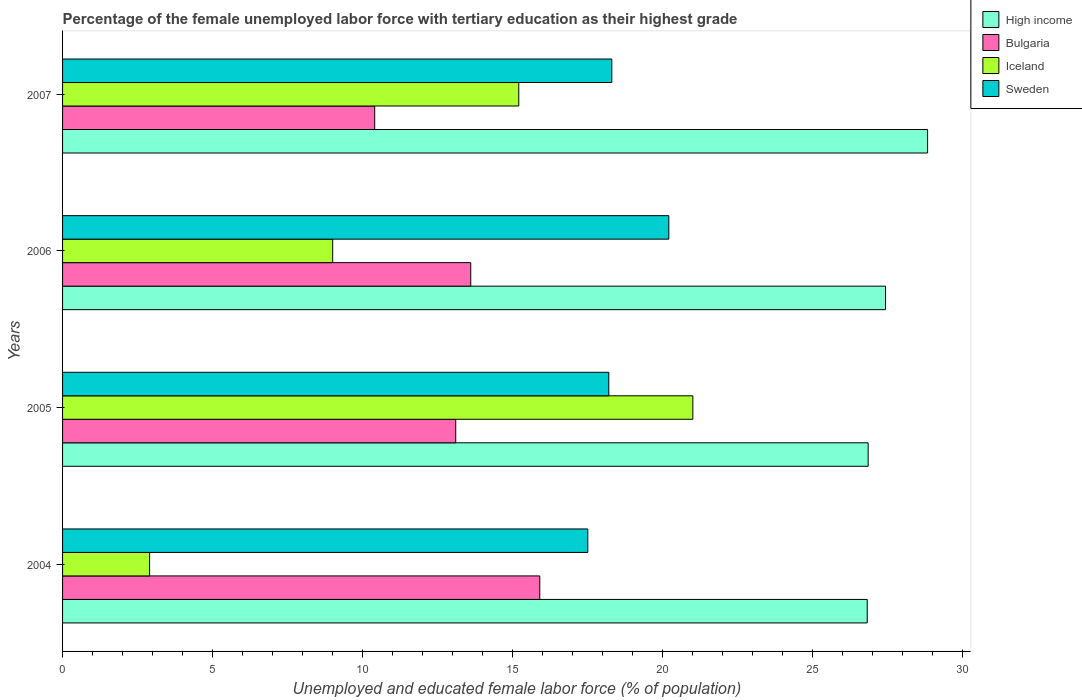How many groups of bars are there?
Make the answer very short. 4. Are the number of bars per tick equal to the number of legend labels?
Your answer should be very brief. Yes. How many bars are there on the 1st tick from the top?
Make the answer very short. 4. How many bars are there on the 4th tick from the bottom?
Provide a short and direct response. 4. What is the label of the 1st group of bars from the top?
Provide a succinct answer. 2007. What is the percentage of the unemployed female labor force with tertiary education in High income in 2007?
Your response must be concise. 28.82. Across all years, what is the minimum percentage of the unemployed female labor force with tertiary education in Iceland?
Your answer should be very brief. 2.9. In which year was the percentage of the unemployed female labor force with tertiary education in Iceland maximum?
Keep it short and to the point. 2005. In which year was the percentage of the unemployed female labor force with tertiary education in Bulgaria minimum?
Provide a succinct answer. 2007. What is the total percentage of the unemployed female labor force with tertiary education in Iceland in the graph?
Give a very brief answer. 48.1. What is the difference between the percentage of the unemployed female labor force with tertiary education in Sweden in 2005 and that in 2007?
Give a very brief answer. -0.1. What is the difference between the percentage of the unemployed female labor force with tertiary education in High income in 2004 and the percentage of the unemployed female labor force with tertiary education in Iceland in 2006?
Your response must be concise. 17.81. What is the average percentage of the unemployed female labor force with tertiary education in Sweden per year?
Keep it short and to the point. 18.55. In the year 2004, what is the difference between the percentage of the unemployed female labor force with tertiary education in Bulgaria and percentage of the unemployed female labor force with tertiary education in High income?
Make the answer very short. -10.91. In how many years, is the percentage of the unemployed female labor force with tertiary education in Iceland greater than 17 %?
Your response must be concise. 1. What is the ratio of the percentage of the unemployed female labor force with tertiary education in Sweden in 2006 to that in 2007?
Your response must be concise. 1.1. Is the percentage of the unemployed female labor force with tertiary education in Iceland in 2005 less than that in 2007?
Make the answer very short. No. Is the difference between the percentage of the unemployed female labor force with tertiary education in Bulgaria in 2005 and 2006 greater than the difference between the percentage of the unemployed female labor force with tertiary education in High income in 2005 and 2006?
Offer a terse response. Yes. What is the difference between the highest and the second highest percentage of the unemployed female labor force with tertiary education in Iceland?
Ensure brevity in your answer.  5.8. What is the difference between the highest and the lowest percentage of the unemployed female labor force with tertiary education in Iceland?
Your answer should be very brief. 18.1. What does the 2nd bar from the top in 2007 represents?
Your answer should be compact. Iceland. What does the 4th bar from the bottom in 2004 represents?
Your answer should be compact. Sweden. Is it the case that in every year, the sum of the percentage of the unemployed female labor force with tertiary education in Sweden and percentage of the unemployed female labor force with tertiary education in Iceland is greater than the percentage of the unemployed female labor force with tertiary education in High income?
Keep it short and to the point. No. Are the values on the major ticks of X-axis written in scientific E-notation?
Offer a very short reply. No. Does the graph contain any zero values?
Offer a very short reply. No. How are the legend labels stacked?
Provide a succinct answer. Vertical. What is the title of the graph?
Make the answer very short. Percentage of the female unemployed labor force with tertiary education as their highest grade. Does "Nigeria" appear as one of the legend labels in the graph?
Provide a succinct answer. No. What is the label or title of the X-axis?
Offer a terse response. Unemployed and educated female labor force (% of population). What is the label or title of the Y-axis?
Your answer should be compact. Years. What is the Unemployed and educated female labor force (% of population) in High income in 2004?
Give a very brief answer. 26.81. What is the Unemployed and educated female labor force (% of population) of Bulgaria in 2004?
Provide a succinct answer. 15.9. What is the Unemployed and educated female labor force (% of population) in Iceland in 2004?
Your answer should be compact. 2.9. What is the Unemployed and educated female labor force (% of population) in High income in 2005?
Offer a terse response. 26.84. What is the Unemployed and educated female labor force (% of population) in Bulgaria in 2005?
Give a very brief answer. 13.1. What is the Unemployed and educated female labor force (% of population) in Iceland in 2005?
Keep it short and to the point. 21. What is the Unemployed and educated female labor force (% of population) of Sweden in 2005?
Your answer should be very brief. 18.2. What is the Unemployed and educated female labor force (% of population) of High income in 2006?
Your answer should be very brief. 27.42. What is the Unemployed and educated female labor force (% of population) in Bulgaria in 2006?
Provide a short and direct response. 13.6. What is the Unemployed and educated female labor force (% of population) of Sweden in 2006?
Your answer should be compact. 20.2. What is the Unemployed and educated female labor force (% of population) in High income in 2007?
Your response must be concise. 28.82. What is the Unemployed and educated female labor force (% of population) of Bulgaria in 2007?
Offer a very short reply. 10.4. What is the Unemployed and educated female labor force (% of population) of Iceland in 2007?
Ensure brevity in your answer.  15.2. What is the Unemployed and educated female labor force (% of population) of Sweden in 2007?
Provide a succinct answer. 18.3. Across all years, what is the maximum Unemployed and educated female labor force (% of population) of High income?
Provide a short and direct response. 28.82. Across all years, what is the maximum Unemployed and educated female labor force (% of population) in Bulgaria?
Your response must be concise. 15.9. Across all years, what is the maximum Unemployed and educated female labor force (% of population) of Sweden?
Make the answer very short. 20.2. Across all years, what is the minimum Unemployed and educated female labor force (% of population) in High income?
Your answer should be very brief. 26.81. Across all years, what is the minimum Unemployed and educated female labor force (% of population) in Bulgaria?
Provide a succinct answer. 10.4. Across all years, what is the minimum Unemployed and educated female labor force (% of population) of Iceland?
Your response must be concise. 2.9. What is the total Unemployed and educated female labor force (% of population) of High income in the graph?
Ensure brevity in your answer.  109.89. What is the total Unemployed and educated female labor force (% of population) of Bulgaria in the graph?
Give a very brief answer. 53. What is the total Unemployed and educated female labor force (% of population) of Iceland in the graph?
Offer a terse response. 48.1. What is the total Unemployed and educated female labor force (% of population) in Sweden in the graph?
Provide a succinct answer. 74.2. What is the difference between the Unemployed and educated female labor force (% of population) of High income in 2004 and that in 2005?
Your response must be concise. -0.03. What is the difference between the Unemployed and educated female labor force (% of population) in Iceland in 2004 and that in 2005?
Your answer should be very brief. -18.1. What is the difference between the Unemployed and educated female labor force (% of population) of Sweden in 2004 and that in 2005?
Your response must be concise. -0.7. What is the difference between the Unemployed and educated female labor force (% of population) of High income in 2004 and that in 2006?
Your response must be concise. -0.61. What is the difference between the Unemployed and educated female labor force (% of population) of Bulgaria in 2004 and that in 2006?
Offer a very short reply. 2.3. What is the difference between the Unemployed and educated female labor force (% of population) in High income in 2004 and that in 2007?
Your response must be concise. -2.01. What is the difference between the Unemployed and educated female labor force (% of population) in Iceland in 2004 and that in 2007?
Ensure brevity in your answer.  -12.3. What is the difference between the Unemployed and educated female labor force (% of population) in Sweden in 2004 and that in 2007?
Your response must be concise. -0.8. What is the difference between the Unemployed and educated female labor force (% of population) in High income in 2005 and that in 2006?
Ensure brevity in your answer.  -0.58. What is the difference between the Unemployed and educated female labor force (% of population) of Bulgaria in 2005 and that in 2006?
Ensure brevity in your answer.  -0.5. What is the difference between the Unemployed and educated female labor force (% of population) of Iceland in 2005 and that in 2006?
Keep it short and to the point. 12. What is the difference between the Unemployed and educated female labor force (% of population) of Sweden in 2005 and that in 2006?
Provide a short and direct response. -2. What is the difference between the Unemployed and educated female labor force (% of population) in High income in 2005 and that in 2007?
Your answer should be very brief. -1.98. What is the difference between the Unemployed and educated female labor force (% of population) of Sweden in 2005 and that in 2007?
Ensure brevity in your answer.  -0.1. What is the difference between the Unemployed and educated female labor force (% of population) in High income in 2006 and that in 2007?
Offer a very short reply. -1.4. What is the difference between the Unemployed and educated female labor force (% of population) in Bulgaria in 2006 and that in 2007?
Offer a terse response. 3.2. What is the difference between the Unemployed and educated female labor force (% of population) of High income in 2004 and the Unemployed and educated female labor force (% of population) of Bulgaria in 2005?
Ensure brevity in your answer.  13.71. What is the difference between the Unemployed and educated female labor force (% of population) of High income in 2004 and the Unemployed and educated female labor force (% of population) of Iceland in 2005?
Ensure brevity in your answer.  5.81. What is the difference between the Unemployed and educated female labor force (% of population) in High income in 2004 and the Unemployed and educated female labor force (% of population) in Sweden in 2005?
Your response must be concise. 8.61. What is the difference between the Unemployed and educated female labor force (% of population) of Bulgaria in 2004 and the Unemployed and educated female labor force (% of population) of Sweden in 2005?
Ensure brevity in your answer.  -2.3. What is the difference between the Unemployed and educated female labor force (% of population) of Iceland in 2004 and the Unemployed and educated female labor force (% of population) of Sweden in 2005?
Keep it short and to the point. -15.3. What is the difference between the Unemployed and educated female labor force (% of population) of High income in 2004 and the Unemployed and educated female labor force (% of population) of Bulgaria in 2006?
Offer a terse response. 13.21. What is the difference between the Unemployed and educated female labor force (% of population) of High income in 2004 and the Unemployed and educated female labor force (% of population) of Iceland in 2006?
Your answer should be compact. 17.81. What is the difference between the Unemployed and educated female labor force (% of population) of High income in 2004 and the Unemployed and educated female labor force (% of population) of Sweden in 2006?
Make the answer very short. 6.61. What is the difference between the Unemployed and educated female labor force (% of population) in Iceland in 2004 and the Unemployed and educated female labor force (% of population) in Sweden in 2006?
Ensure brevity in your answer.  -17.3. What is the difference between the Unemployed and educated female labor force (% of population) in High income in 2004 and the Unemployed and educated female labor force (% of population) in Bulgaria in 2007?
Make the answer very short. 16.41. What is the difference between the Unemployed and educated female labor force (% of population) in High income in 2004 and the Unemployed and educated female labor force (% of population) in Iceland in 2007?
Your response must be concise. 11.61. What is the difference between the Unemployed and educated female labor force (% of population) of High income in 2004 and the Unemployed and educated female labor force (% of population) of Sweden in 2007?
Ensure brevity in your answer.  8.51. What is the difference between the Unemployed and educated female labor force (% of population) in Iceland in 2004 and the Unemployed and educated female labor force (% of population) in Sweden in 2007?
Make the answer very short. -15.4. What is the difference between the Unemployed and educated female labor force (% of population) of High income in 2005 and the Unemployed and educated female labor force (% of population) of Bulgaria in 2006?
Keep it short and to the point. 13.24. What is the difference between the Unemployed and educated female labor force (% of population) in High income in 2005 and the Unemployed and educated female labor force (% of population) in Iceland in 2006?
Offer a very short reply. 17.84. What is the difference between the Unemployed and educated female labor force (% of population) in High income in 2005 and the Unemployed and educated female labor force (% of population) in Sweden in 2006?
Ensure brevity in your answer.  6.64. What is the difference between the Unemployed and educated female labor force (% of population) of Iceland in 2005 and the Unemployed and educated female labor force (% of population) of Sweden in 2006?
Offer a terse response. 0.8. What is the difference between the Unemployed and educated female labor force (% of population) of High income in 2005 and the Unemployed and educated female labor force (% of population) of Bulgaria in 2007?
Your response must be concise. 16.44. What is the difference between the Unemployed and educated female labor force (% of population) of High income in 2005 and the Unemployed and educated female labor force (% of population) of Iceland in 2007?
Provide a short and direct response. 11.64. What is the difference between the Unemployed and educated female labor force (% of population) in High income in 2005 and the Unemployed and educated female labor force (% of population) in Sweden in 2007?
Your answer should be very brief. 8.54. What is the difference between the Unemployed and educated female labor force (% of population) in Bulgaria in 2005 and the Unemployed and educated female labor force (% of population) in Sweden in 2007?
Ensure brevity in your answer.  -5.2. What is the difference between the Unemployed and educated female labor force (% of population) in Iceland in 2005 and the Unemployed and educated female labor force (% of population) in Sweden in 2007?
Provide a short and direct response. 2.7. What is the difference between the Unemployed and educated female labor force (% of population) of High income in 2006 and the Unemployed and educated female labor force (% of population) of Bulgaria in 2007?
Offer a very short reply. 17.02. What is the difference between the Unemployed and educated female labor force (% of population) of High income in 2006 and the Unemployed and educated female labor force (% of population) of Iceland in 2007?
Keep it short and to the point. 12.22. What is the difference between the Unemployed and educated female labor force (% of population) of High income in 2006 and the Unemployed and educated female labor force (% of population) of Sweden in 2007?
Offer a terse response. 9.12. What is the difference between the Unemployed and educated female labor force (% of population) in Bulgaria in 2006 and the Unemployed and educated female labor force (% of population) in Iceland in 2007?
Your response must be concise. -1.6. What is the difference between the Unemployed and educated female labor force (% of population) in Iceland in 2006 and the Unemployed and educated female labor force (% of population) in Sweden in 2007?
Your response must be concise. -9.3. What is the average Unemployed and educated female labor force (% of population) of High income per year?
Your answer should be very brief. 27.47. What is the average Unemployed and educated female labor force (% of population) of Bulgaria per year?
Give a very brief answer. 13.25. What is the average Unemployed and educated female labor force (% of population) of Iceland per year?
Provide a succinct answer. 12.03. What is the average Unemployed and educated female labor force (% of population) in Sweden per year?
Your answer should be compact. 18.55. In the year 2004, what is the difference between the Unemployed and educated female labor force (% of population) in High income and Unemployed and educated female labor force (% of population) in Bulgaria?
Provide a short and direct response. 10.91. In the year 2004, what is the difference between the Unemployed and educated female labor force (% of population) in High income and Unemployed and educated female labor force (% of population) in Iceland?
Keep it short and to the point. 23.91. In the year 2004, what is the difference between the Unemployed and educated female labor force (% of population) of High income and Unemployed and educated female labor force (% of population) of Sweden?
Your response must be concise. 9.31. In the year 2004, what is the difference between the Unemployed and educated female labor force (% of population) of Bulgaria and Unemployed and educated female labor force (% of population) of Sweden?
Keep it short and to the point. -1.6. In the year 2004, what is the difference between the Unemployed and educated female labor force (% of population) in Iceland and Unemployed and educated female labor force (% of population) in Sweden?
Your response must be concise. -14.6. In the year 2005, what is the difference between the Unemployed and educated female labor force (% of population) in High income and Unemployed and educated female labor force (% of population) in Bulgaria?
Ensure brevity in your answer.  13.74. In the year 2005, what is the difference between the Unemployed and educated female labor force (% of population) of High income and Unemployed and educated female labor force (% of population) of Iceland?
Provide a short and direct response. 5.84. In the year 2005, what is the difference between the Unemployed and educated female labor force (% of population) in High income and Unemployed and educated female labor force (% of population) in Sweden?
Keep it short and to the point. 8.64. In the year 2005, what is the difference between the Unemployed and educated female labor force (% of population) of Bulgaria and Unemployed and educated female labor force (% of population) of Iceland?
Ensure brevity in your answer.  -7.9. In the year 2006, what is the difference between the Unemployed and educated female labor force (% of population) of High income and Unemployed and educated female labor force (% of population) of Bulgaria?
Provide a short and direct response. 13.82. In the year 2006, what is the difference between the Unemployed and educated female labor force (% of population) in High income and Unemployed and educated female labor force (% of population) in Iceland?
Your answer should be compact. 18.42. In the year 2006, what is the difference between the Unemployed and educated female labor force (% of population) in High income and Unemployed and educated female labor force (% of population) in Sweden?
Provide a succinct answer. 7.22. In the year 2006, what is the difference between the Unemployed and educated female labor force (% of population) of Bulgaria and Unemployed and educated female labor force (% of population) of Iceland?
Provide a short and direct response. 4.6. In the year 2006, what is the difference between the Unemployed and educated female labor force (% of population) of Iceland and Unemployed and educated female labor force (% of population) of Sweden?
Keep it short and to the point. -11.2. In the year 2007, what is the difference between the Unemployed and educated female labor force (% of population) in High income and Unemployed and educated female labor force (% of population) in Bulgaria?
Give a very brief answer. 18.42. In the year 2007, what is the difference between the Unemployed and educated female labor force (% of population) of High income and Unemployed and educated female labor force (% of population) of Iceland?
Offer a terse response. 13.62. In the year 2007, what is the difference between the Unemployed and educated female labor force (% of population) in High income and Unemployed and educated female labor force (% of population) in Sweden?
Give a very brief answer. 10.52. In the year 2007, what is the difference between the Unemployed and educated female labor force (% of population) in Bulgaria and Unemployed and educated female labor force (% of population) in Iceland?
Make the answer very short. -4.8. In the year 2007, what is the difference between the Unemployed and educated female labor force (% of population) of Iceland and Unemployed and educated female labor force (% of population) of Sweden?
Provide a succinct answer. -3.1. What is the ratio of the Unemployed and educated female labor force (% of population) in High income in 2004 to that in 2005?
Provide a succinct answer. 1. What is the ratio of the Unemployed and educated female labor force (% of population) of Bulgaria in 2004 to that in 2005?
Offer a terse response. 1.21. What is the ratio of the Unemployed and educated female labor force (% of population) in Iceland in 2004 to that in 2005?
Ensure brevity in your answer.  0.14. What is the ratio of the Unemployed and educated female labor force (% of population) in Sweden in 2004 to that in 2005?
Offer a terse response. 0.96. What is the ratio of the Unemployed and educated female labor force (% of population) of High income in 2004 to that in 2006?
Provide a succinct answer. 0.98. What is the ratio of the Unemployed and educated female labor force (% of population) of Bulgaria in 2004 to that in 2006?
Provide a short and direct response. 1.17. What is the ratio of the Unemployed and educated female labor force (% of population) of Iceland in 2004 to that in 2006?
Your response must be concise. 0.32. What is the ratio of the Unemployed and educated female labor force (% of population) in Sweden in 2004 to that in 2006?
Ensure brevity in your answer.  0.87. What is the ratio of the Unemployed and educated female labor force (% of population) of High income in 2004 to that in 2007?
Ensure brevity in your answer.  0.93. What is the ratio of the Unemployed and educated female labor force (% of population) of Bulgaria in 2004 to that in 2007?
Your answer should be compact. 1.53. What is the ratio of the Unemployed and educated female labor force (% of population) of Iceland in 2004 to that in 2007?
Offer a terse response. 0.19. What is the ratio of the Unemployed and educated female labor force (% of population) in Sweden in 2004 to that in 2007?
Provide a short and direct response. 0.96. What is the ratio of the Unemployed and educated female labor force (% of population) of High income in 2005 to that in 2006?
Make the answer very short. 0.98. What is the ratio of the Unemployed and educated female labor force (% of population) in Bulgaria in 2005 to that in 2006?
Make the answer very short. 0.96. What is the ratio of the Unemployed and educated female labor force (% of population) in Iceland in 2005 to that in 2006?
Your answer should be compact. 2.33. What is the ratio of the Unemployed and educated female labor force (% of population) of Sweden in 2005 to that in 2006?
Make the answer very short. 0.9. What is the ratio of the Unemployed and educated female labor force (% of population) of High income in 2005 to that in 2007?
Your answer should be very brief. 0.93. What is the ratio of the Unemployed and educated female labor force (% of population) in Bulgaria in 2005 to that in 2007?
Provide a short and direct response. 1.26. What is the ratio of the Unemployed and educated female labor force (% of population) of Iceland in 2005 to that in 2007?
Ensure brevity in your answer.  1.38. What is the ratio of the Unemployed and educated female labor force (% of population) of High income in 2006 to that in 2007?
Provide a short and direct response. 0.95. What is the ratio of the Unemployed and educated female labor force (% of population) of Bulgaria in 2006 to that in 2007?
Ensure brevity in your answer.  1.31. What is the ratio of the Unemployed and educated female labor force (% of population) in Iceland in 2006 to that in 2007?
Your response must be concise. 0.59. What is the ratio of the Unemployed and educated female labor force (% of population) of Sweden in 2006 to that in 2007?
Offer a very short reply. 1.1. What is the difference between the highest and the second highest Unemployed and educated female labor force (% of population) of High income?
Offer a terse response. 1.4. What is the difference between the highest and the second highest Unemployed and educated female labor force (% of population) of Iceland?
Ensure brevity in your answer.  5.8. What is the difference between the highest and the second highest Unemployed and educated female labor force (% of population) in Sweden?
Keep it short and to the point. 1.9. What is the difference between the highest and the lowest Unemployed and educated female labor force (% of population) of High income?
Give a very brief answer. 2.01. What is the difference between the highest and the lowest Unemployed and educated female labor force (% of population) in Bulgaria?
Provide a short and direct response. 5.5. What is the difference between the highest and the lowest Unemployed and educated female labor force (% of population) in Iceland?
Provide a succinct answer. 18.1. What is the difference between the highest and the lowest Unemployed and educated female labor force (% of population) in Sweden?
Provide a short and direct response. 2.7. 